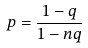<formula> <loc_0><loc_0><loc_500><loc_500>p = \frac { 1 - q } { 1 - n q }</formula> 